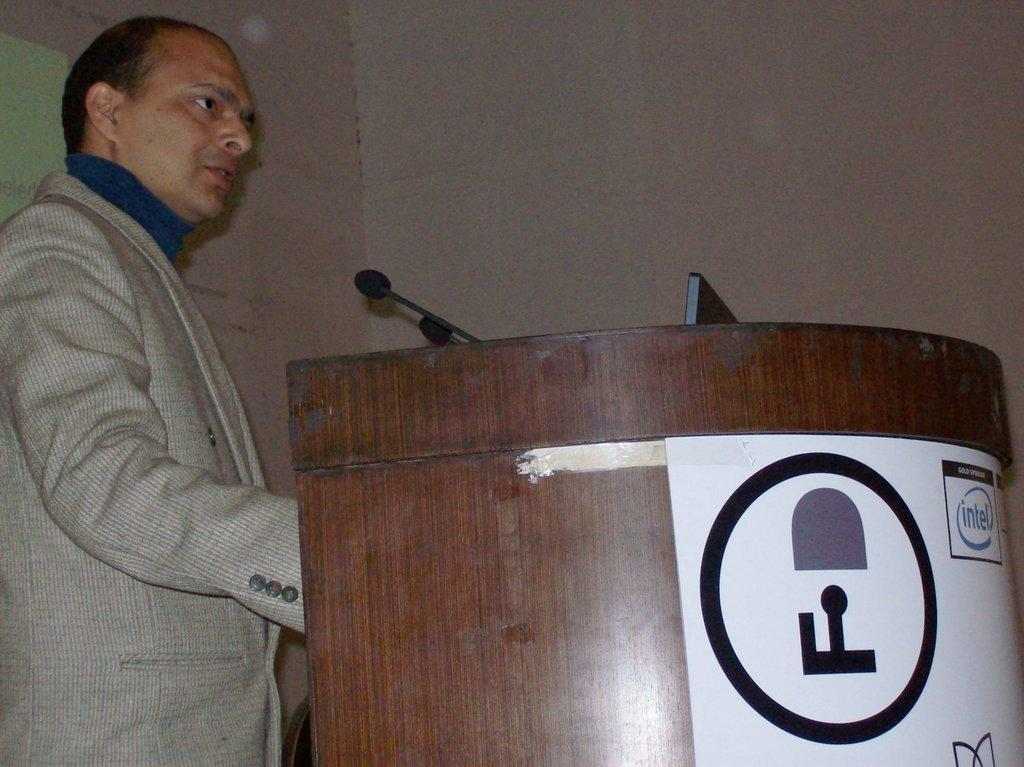What is the person in the image doing? The person is standing at a desk on the left side of the image. What can be seen behind the person? There is a wall in the background of the image. Where is the nest located in the image? There is no nest present in the image. What level of the building is the person standing on? The image does not provide enough information to determine the level of the building. 